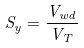<formula> <loc_0><loc_0><loc_500><loc_500>S _ { y } = \frac { V _ { w d } } { V _ { T } }</formula> 